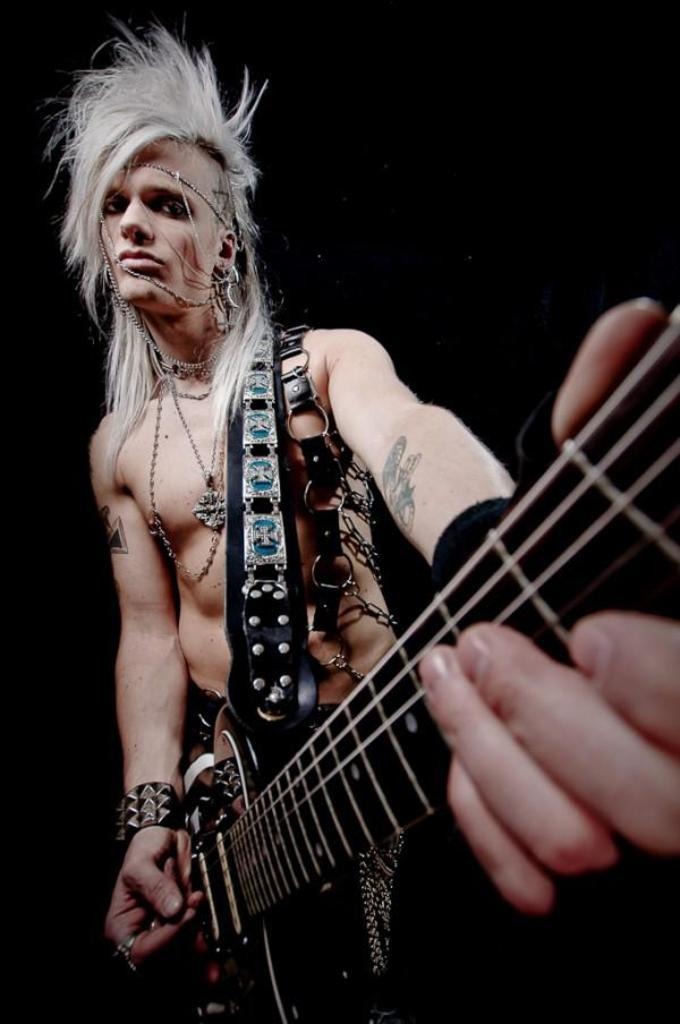What is the main subject of the image? The main subject of the image is a guy. What is the guy doing in the image? The guy is playing a guitar in the image. Can you describe the guy's appearance in the image? The guy is wearing beautiful objects and has a funky hairstyle in the image. What is the color of the background in the image? The background of the image is black in color. Can you tell me how many marbles are on the floor in the image? There are no marbles present in the image; it features a guy playing a guitar. What type of bird is perched on the guy's shoulder in the image? There is no bird, specifically an owl, present in the image. 